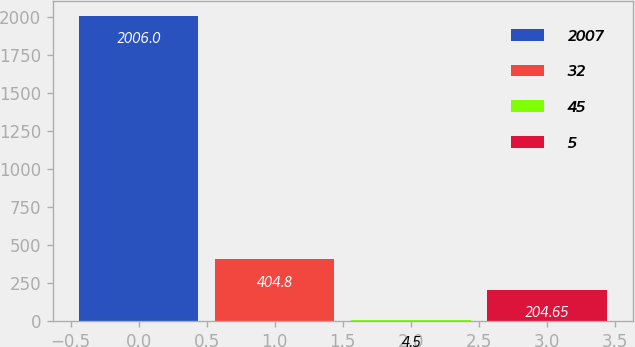Convert chart to OTSL. <chart><loc_0><loc_0><loc_500><loc_500><bar_chart><fcel>2007<fcel>32<fcel>45<fcel>5<nl><fcel>2006<fcel>404.8<fcel>4.5<fcel>204.65<nl></chart> 